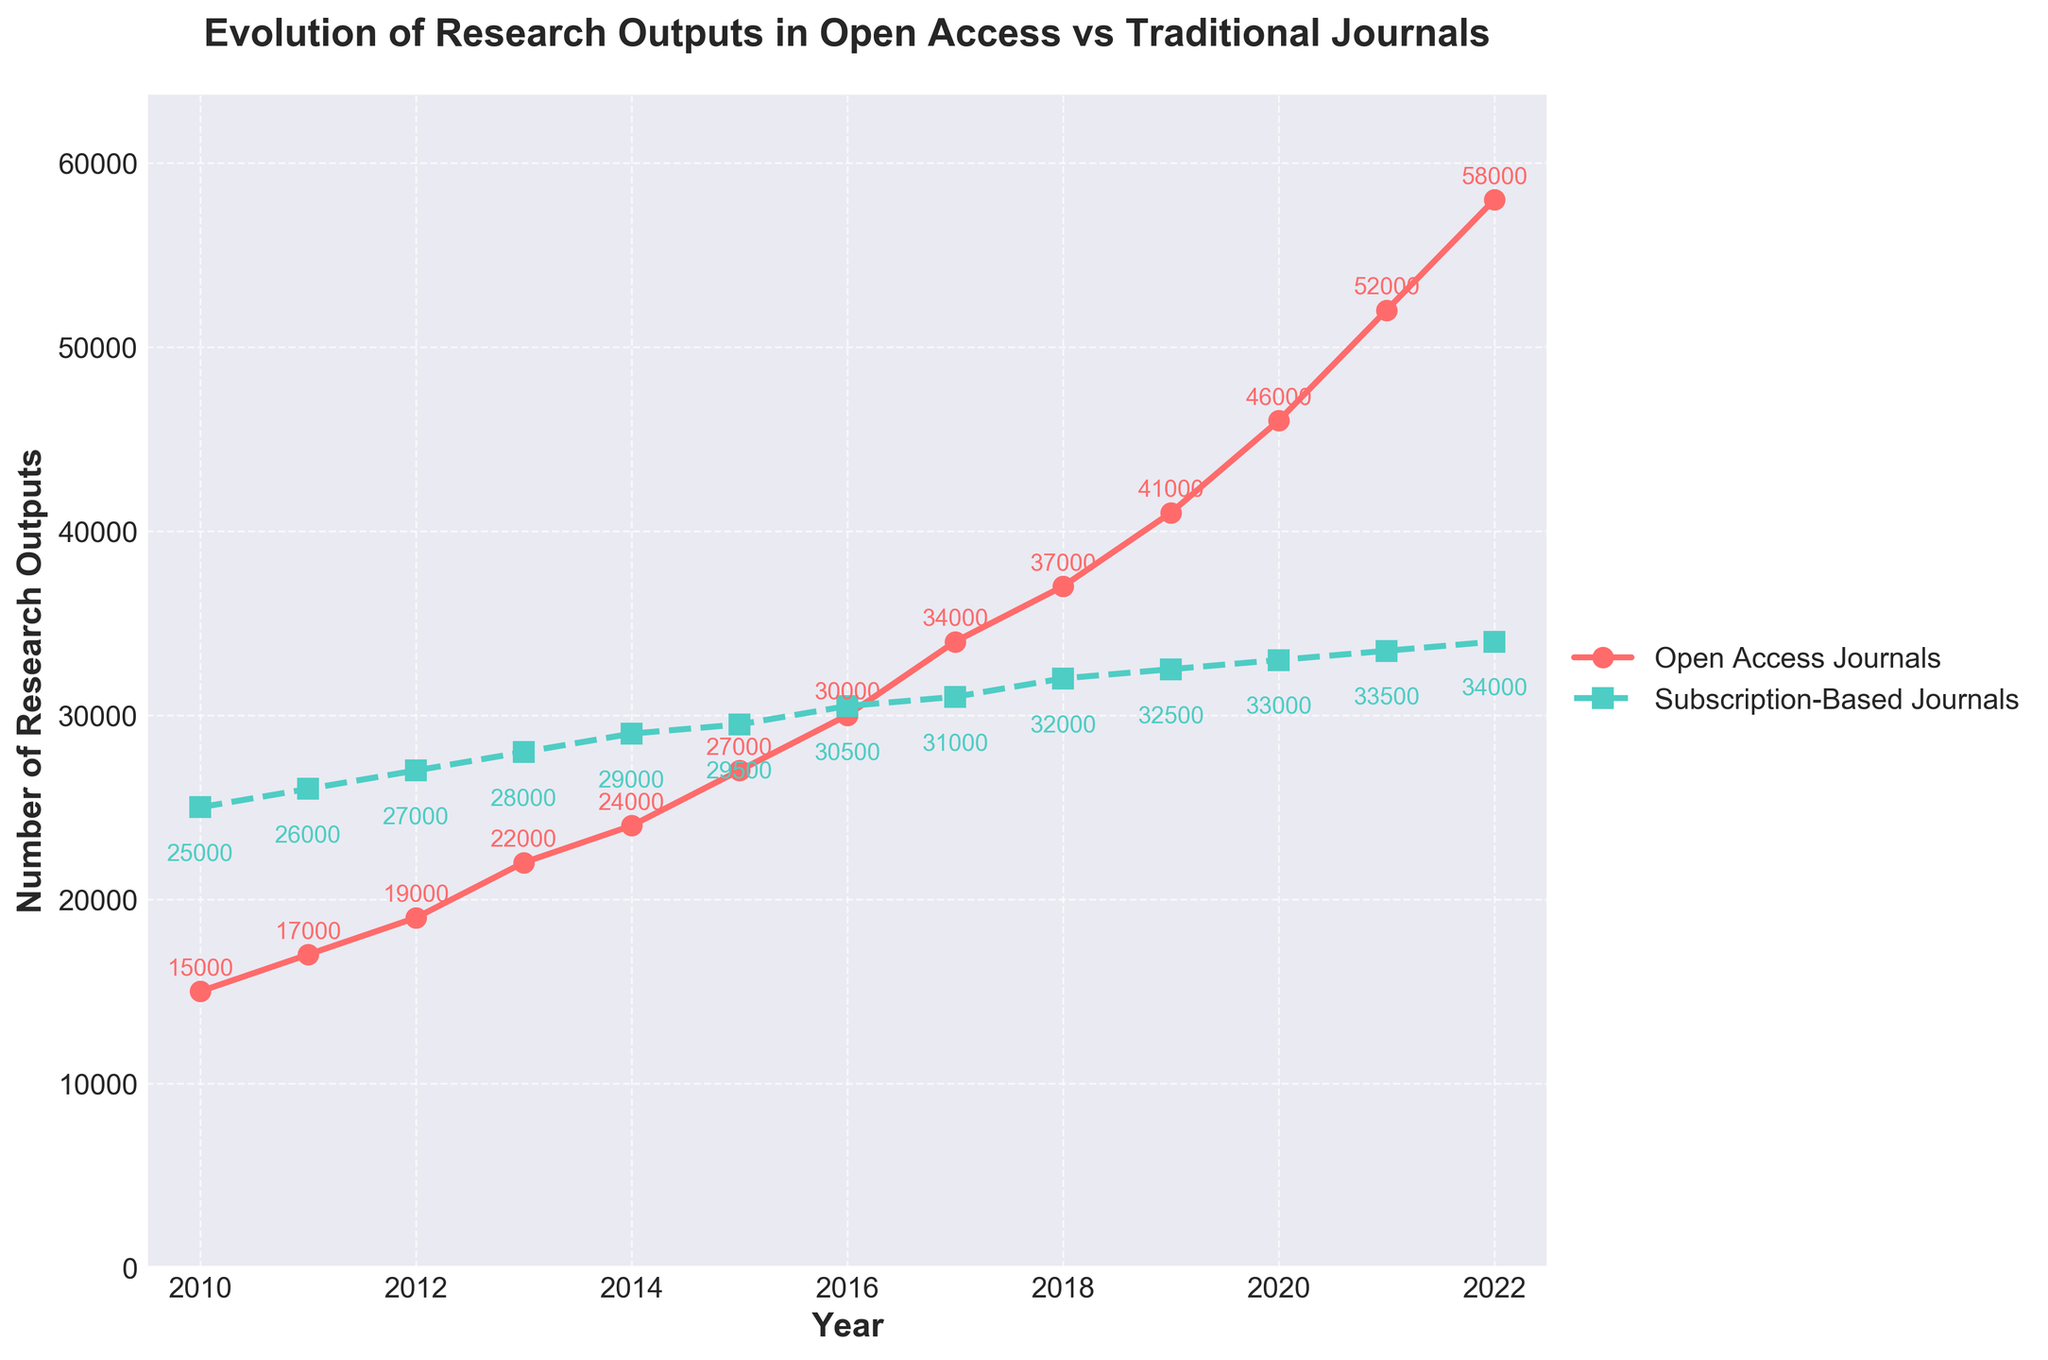What is the title of the plot? The title is prominently displayed at the top of the plot, and it reads 'Evolution of Research Outputs in Open Access vs Traditional Journals'.
Answer: Evolution of Research Outputs in Open Access vs Traditional Journals What are the two categories being compared in the plot? The two categories are identified by the legend and the line styles/colors. They are 'Open Access Journals' (red line with circles) and 'Subscription-Based Journals' (green line with squares).
Answer: Open Access Journals and Subscription-Based Journals In which year did Open Access Journals first surpass Subscription-Based Journals in the number of research outputs? By looking at the plotted lines, we can see that Open Access Journals surpass Subscription-Based Journals in the year 2017 where the red line is above the green line.
Answer: 2017 What is the number of research outputs in Open Access Journals in the year 2015? The red line with circles represents Open Access Journals. For the year 2015, the number next to the circle on the red line is 27,000.
Answer: 27,000 What is the rise in the number of research outputs for Subscription-Based Journals from 2010 to 2022? For Subscription-Based Journals (green line and squares), the number of research outputs in 2010 is 25,000 and rises to 34,000 in 2022. The increase is calculated as 34,000 - 25,000.
Answer: 9,000 How many more research outputs did Open Access Journals have over Subscription-Based Journals in 2022? In 2022, Open Access Journals have 58,000 outputs and Subscription-Based Journals have 34,000 outputs. The difference is 58,000 - 34,000.
Answer: 24,000 Which year showed the most considerable annual increase in research outputs for Open Access Journals? By examining the red line and circle markers, the largest jump appears between 2021 (52,000) and 2022 (58,000). The increase here is 6,000, the largest among the yearly changes.
Answer: 2022 What is the average number of research outputs in Subscription-Based Journals over the years shown? First, sum up all Subscription-Based Journals data points (25,000 + 26,000 + 27,000 + 28,000 + 29,000 + 29,500 + 30,500 + 31,000 + 32,000 + 32,500 + 33,000 + 33,500 + 34,000). Then divide this sum by the total number of years (13).
Answer: 30,962 Is there any year where the research outputs in Subscription-Based Journals remained the same as the previous year? Observing the green line and square markers, between the years 2014 and 2015, the number remains nearly the same (29,000 and 29,500). Technically, no exact year shows a complete absence of change, but these two are the closest.
Answer: No Describe the overall trend in research outputs in Open Access Journals from 2010 to 2022. By following the red line with circles, the research outputs in Open Access Journals show a consistent upward trend, increasing every year without any decline.
Answer: Consistent upward trend 